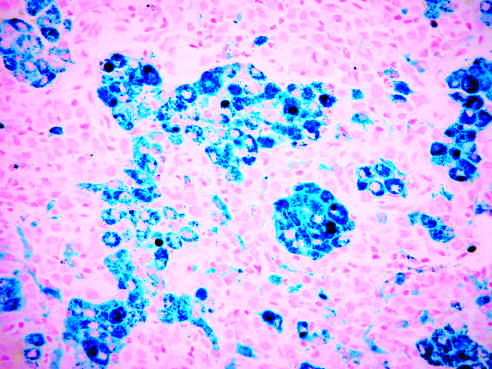what has been stained with prussian blue, an iron stain that highlights the abundant intracellular hemo-siderin?
Answer the question using a single word or phrase. The tissue 